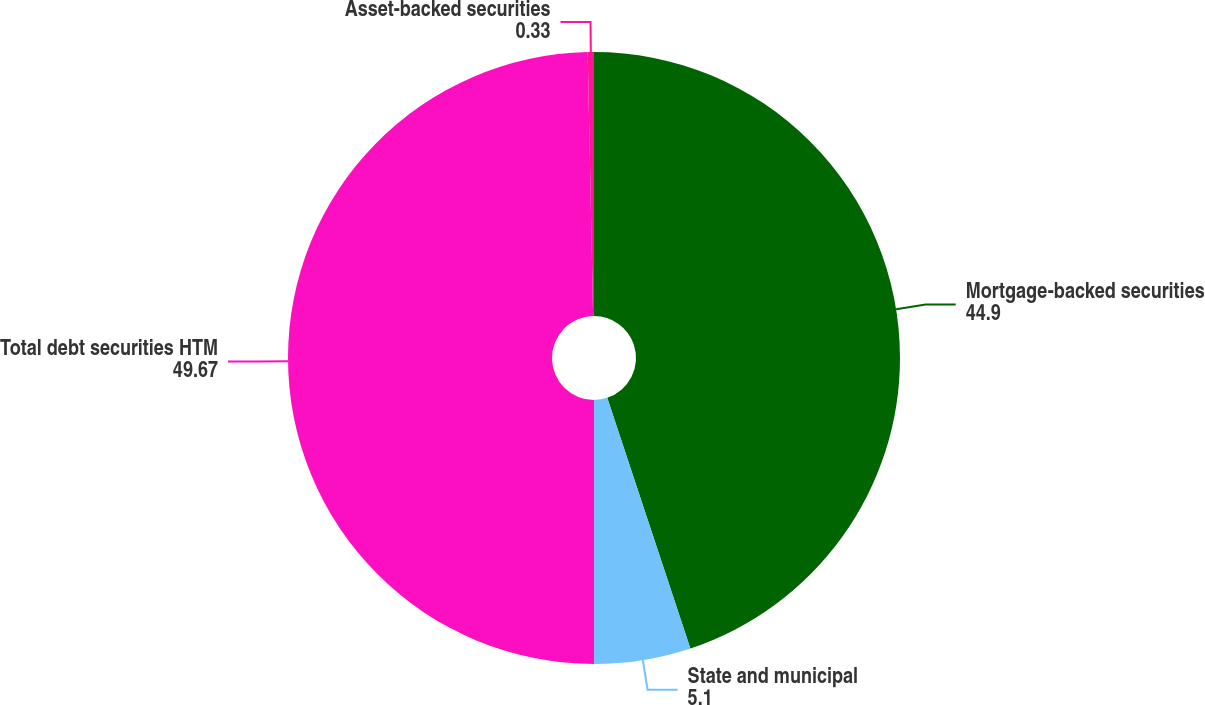Convert chart to OTSL. <chart><loc_0><loc_0><loc_500><loc_500><pie_chart><fcel>Mortgage-backed securities<fcel>State and municipal<fcel>Total debt securities HTM<fcel>Asset-backed securities<nl><fcel>44.9%<fcel>5.1%<fcel>49.67%<fcel>0.33%<nl></chart> 